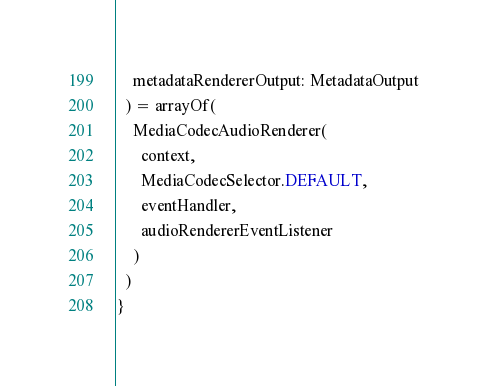Convert code to text. <code><loc_0><loc_0><loc_500><loc_500><_Kotlin_>    metadataRendererOutput: MetadataOutput
  ) = arrayOf(
    MediaCodecAudioRenderer(
      context,
      MediaCodecSelector.DEFAULT,
      eventHandler,
      audioRendererEventListener
    )
  )
}
</code> 